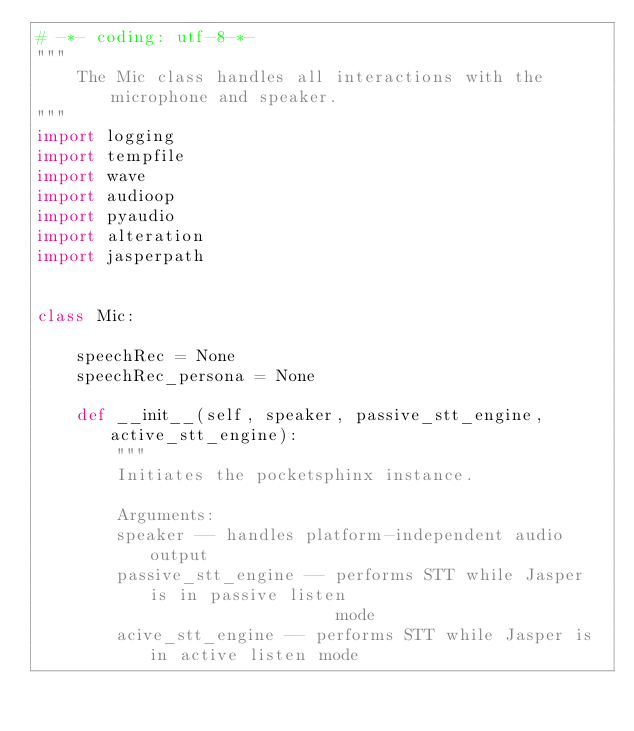Convert code to text. <code><loc_0><loc_0><loc_500><loc_500><_Python_># -*- coding: utf-8-*-
"""
    The Mic class handles all interactions with the microphone and speaker.
"""
import logging
import tempfile
import wave
import audioop
import pyaudio
import alteration
import jasperpath


class Mic:

    speechRec = None
    speechRec_persona = None

    def __init__(self, speaker, passive_stt_engine, active_stt_engine):
        """
        Initiates the pocketsphinx instance.

        Arguments:
        speaker -- handles platform-independent audio output
        passive_stt_engine -- performs STT while Jasper is in passive listen
                              mode
        acive_stt_engine -- performs STT while Jasper is in active listen mode</code> 